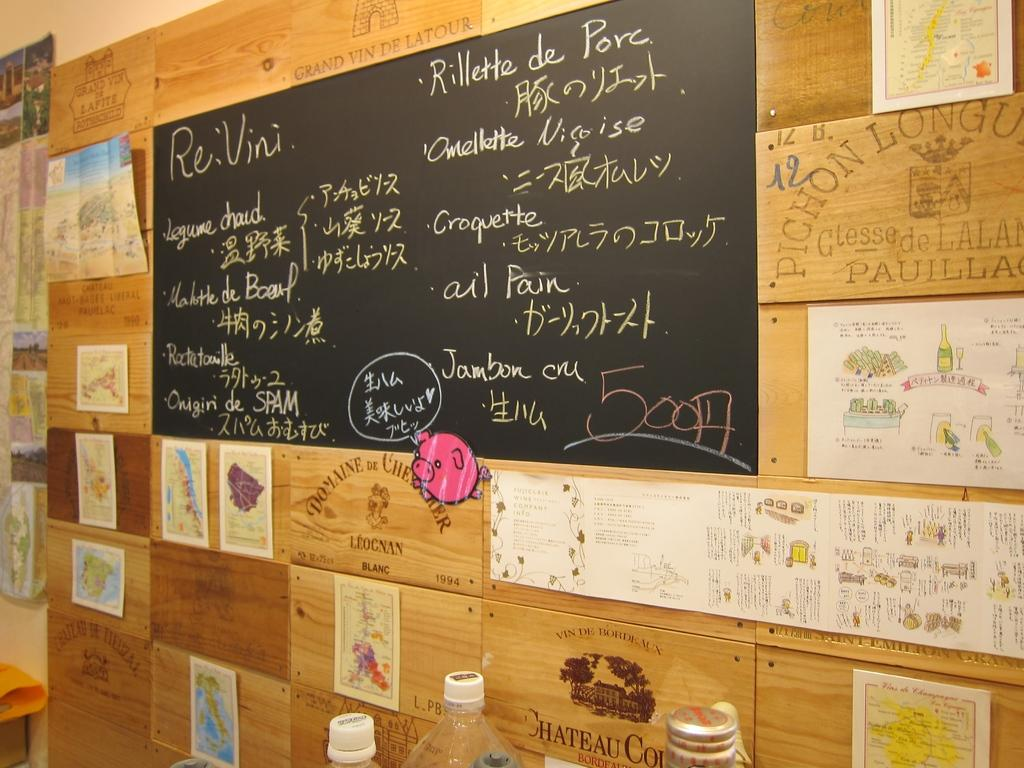<image>
Summarize the visual content of the image. A menu board with food including Omellette on it. 